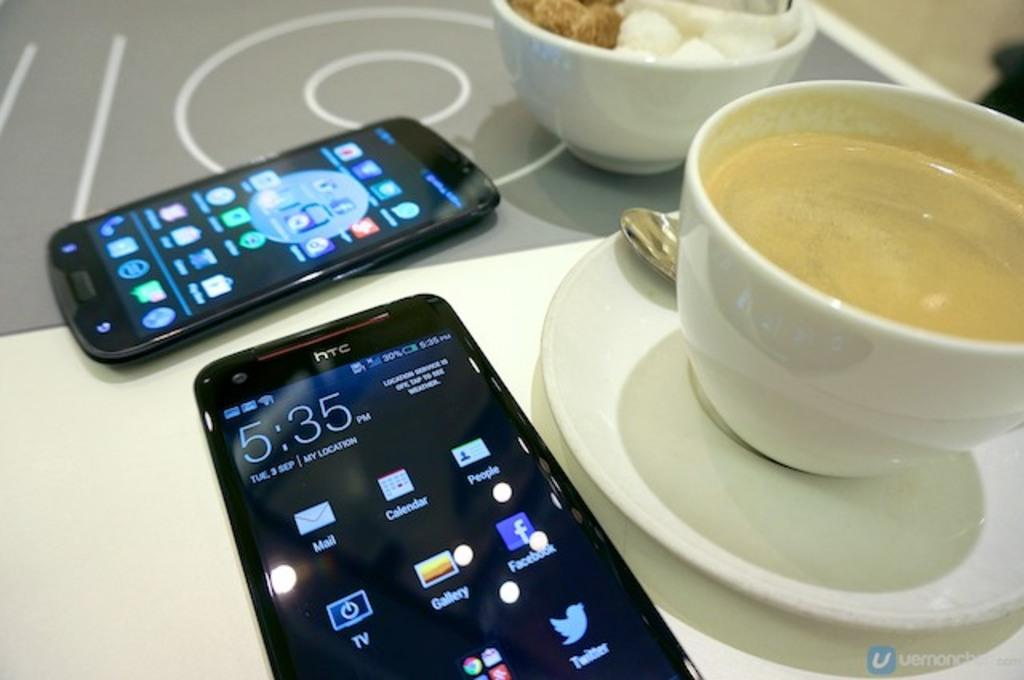<image>
Summarize the visual content of the image. Two htc phones display icons such as Mail, Calendar and the rest. 